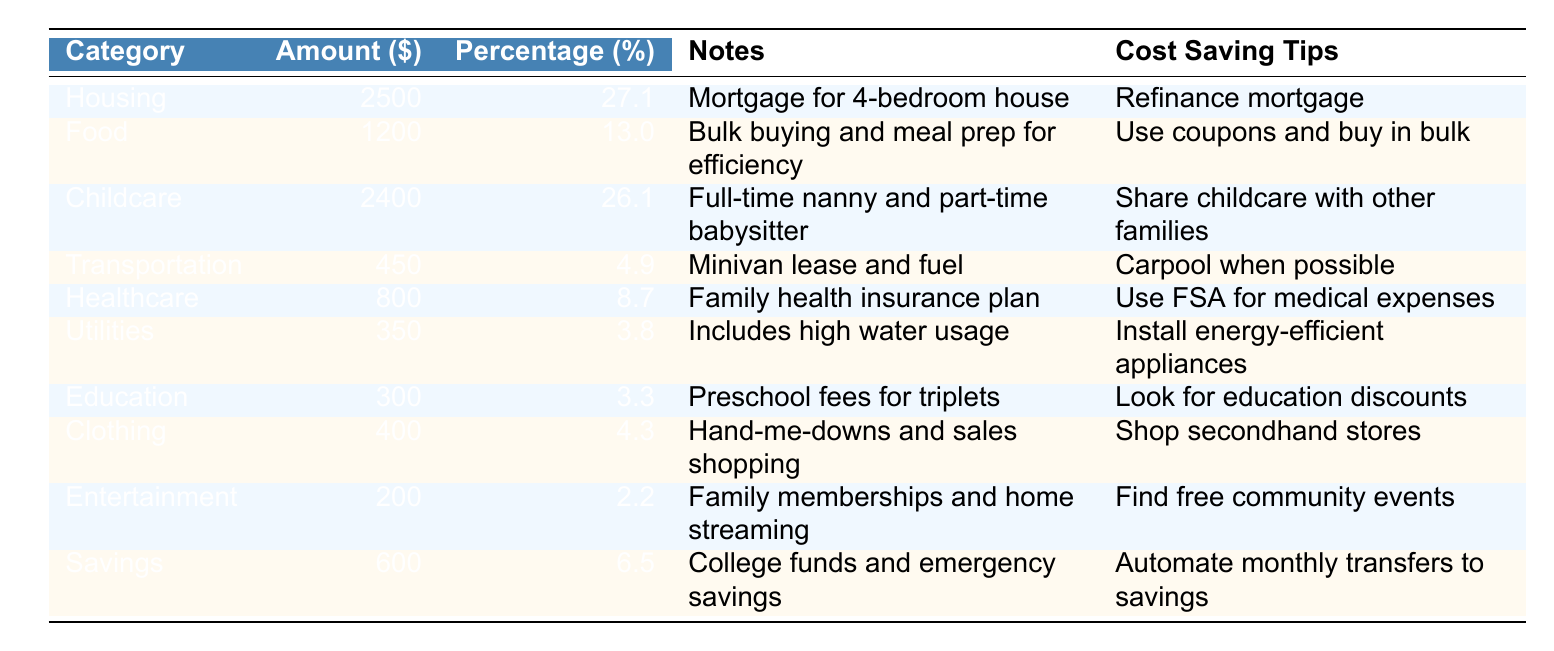What is the highest expense category in the household budget? Looking at the "Amounts" column, the highest value is 2500, which corresponds to the "Housing" category.
Answer: Housing What percentage of the budget is allocated to childcare? The "Childcare" category has an amount of 2400, and its percentage is recorded as 26.1%.
Answer: 26.1% If you add up the expenses for food and clothing, what is the total? Adding the values for "Food" (1200) and "Clothing" (400) gives 1200 + 400 = 1600.
Answer: 1600 Are electricity costs included under the utilities category? The "Utilities" category indicates it includes high water usage, but does not specifically mention electricity costs. Therefore, we cannot confirm it's included.
Answer: No What fraction of the total budget is spent on savings? First, calculate the total budget: 2500 + 1200 + 2400 + 450 + 800 + 350 + 300 + 400 + 200 + 600 =  8000. Savings is 600, so the fraction is 600/8000 = 0.075, which is 7.5%.
Answer: 7.5% Which category has the lowest percentage of the budget? By reviewing the "Percentages" column, "Entertainment" has the lowest percentage at 2.2%.
Answer: Entertainment What is the total expenditure on education and healthcare combined? The "Education" amount is 300 and "Healthcare" is 800. Adding both gives 300 + 800 = 1100.
Answer: 1100 Is the cost-saving tip for food related to any specific strategy? The cost-saving tip listed under "Food" is to "Use coupons and buy in bulk," which implies a specific strategy for reducing food costs.
Answer: Yes What is the difference in spending between housing and transportation? The amount for "Housing" is 2500 and for "Transportation" it is 450. The difference is 2500 - 450 = 2050.
Answer: 2050 How much of the budget is spent on utilities compared to childcare? The "Utilities" amount is 350 and the "Childcare" amount is 2400. The difference is 2400 - 350 = 2050, indicating childcare is much higher.
Answer: 2050 